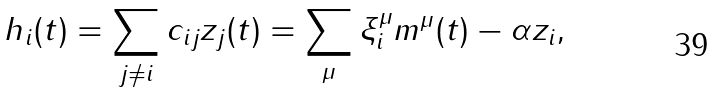<formula> <loc_0><loc_0><loc_500><loc_500>h _ { i } ( t ) = \sum _ { j \ne i } c _ { i j } z _ { j } ( t ) = \sum _ { \mu } \xi _ { i } ^ { \mu } m ^ { \mu } ( t ) - \alpha z _ { i } ,</formula> 